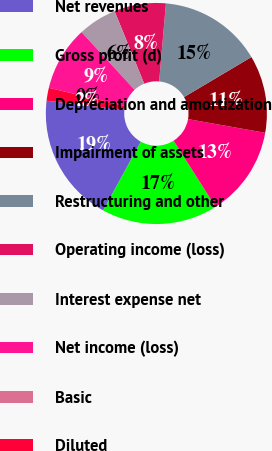<chart> <loc_0><loc_0><loc_500><loc_500><pie_chart><fcel>Net revenues<fcel>Gross profit (d)<fcel>Depreciation and amortization<fcel>Impairment of assets<fcel>Restructuring and other<fcel>Operating income (loss)<fcel>Interest expense net<fcel>Net income (loss)<fcel>Basic<fcel>Diluted<nl><fcel>18.86%<fcel>16.98%<fcel>13.21%<fcel>11.32%<fcel>15.09%<fcel>7.55%<fcel>5.66%<fcel>9.43%<fcel>0.0%<fcel>1.89%<nl></chart> 